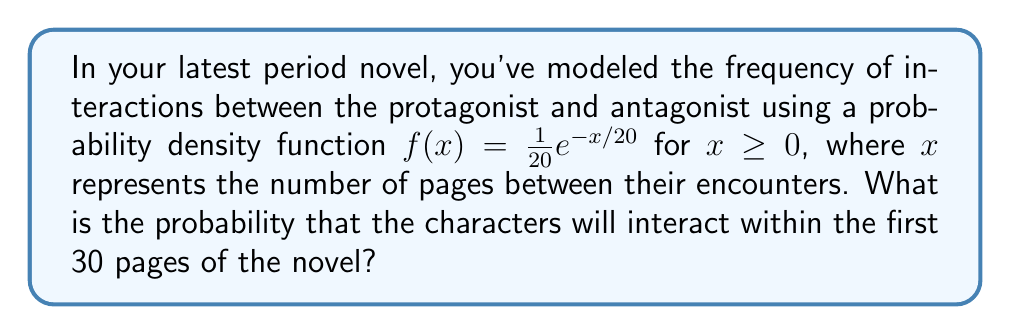Show me your answer to this math problem. To solve this problem, we need to integrate the probability density function over the interval [0, 30]. This will give us the cumulative probability of an interaction occurring within the first 30 pages.

Step 1: Set up the integral
$$P(0 \leq X \leq 30) = \int_0^{30} f(x) dx = \int_0^{30} \frac{1}{20}e^{-x/20} dx$$

Step 2: Solve the integral
$$\begin{align}
P(0 \leq X \leq 30) &= \int_0^{30} \frac{1}{20}e^{-x/20} dx \\
&= -e^{-x/20} \bigg|_0^{30} \\
&= -e^{-30/20} - (-e^{0}) \\
&= -e^{-3/2} + 1 \\
&= 1 - e^{-3/2}
\end{align}$$

Step 3: Calculate the final value
$$1 - e^{-3/2} \approx 0.7769$$

Therefore, the probability that the characters will interact within the first 30 pages of the novel is approximately 0.7769 or 77.69%.
Answer: $1 - e^{-3/2} \approx 0.7769$ 